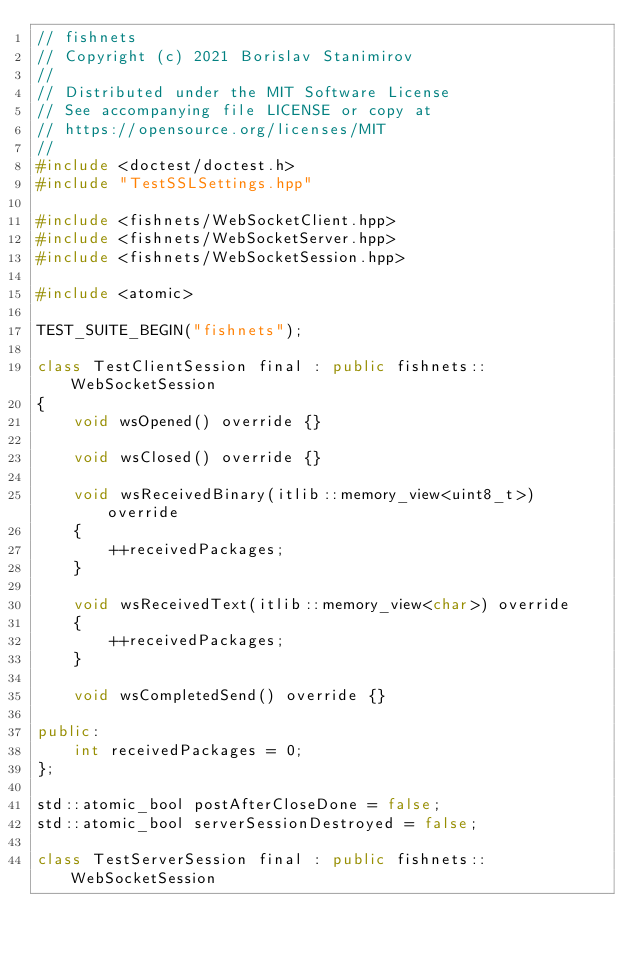Convert code to text. <code><loc_0><loc_0><loc_500><loc_500><_C++_>// fishnets
// Copyright (c) 2021 Borislav Stanimirov
//
// Distributed under the MIT Software License
// See accompanying file LICENSE or copy at
// https://opensource.org/licenses/MIT
//
#include <doctest/doctest.h>
#include "TestSSLSettings.hpp"

#include <fishnets/WebSocketClient.hpp>
#include <fishnets/WebSocketServer.hpp>
#include <fishnets/WebSocketSession.hpp>

#include <atomic>

TEST_SUITE_BEGIN("fishnets");

class TestClientSession final : public fishnets::WebSocketSession
{
    void wsOpened() override {}

    void wsClosed() override {}

    void wsReceivedBinary(itlib::memory_view<uint8_t>) override
    {
        ++receivedPackages;
    }

    void wsReceivedText(itlib::memory_view<char>) override
    {
        ++receivedPackages;
    }

    void wsCompletedSend() override {}

public:
    int receivedPackages = 0;
};

std::atomic_bool postAfterCloseDone = false;
std::atomic_bool serverSessionDestroyed = false;

class TestServerSession final : public fishnets::WebSocketSession</code> 